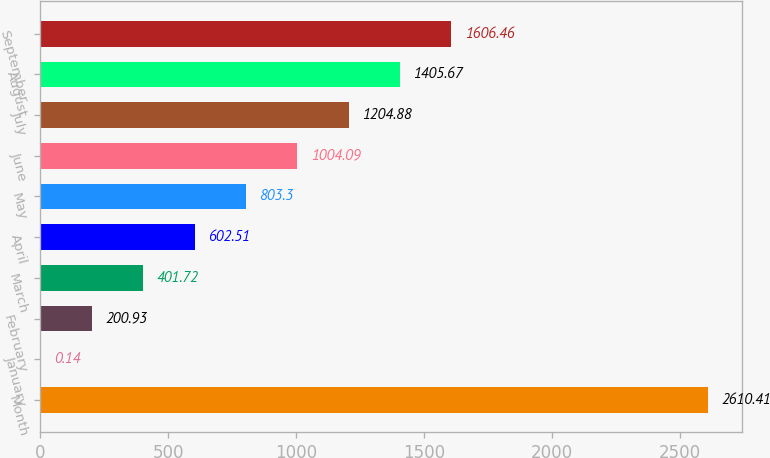Convert chart to OTSL. <chart><loc_0><loc_0><loc_500><loc_500><bar_chart><fcel>Month<fcel>January<fcel>February<fcel>March<fcel>April<fcel>May<fcel>June<fcel>July<fcel>August<fcel>September<nl><fcel>2610.41<fcel>0.14<fcel>200.93<fcel>401.72<fcel>602.51<fcel>803.3<fcel>1004.09<fcel>1204.88<fcel>1405.67<fcel>1606.46<nl></chart> 